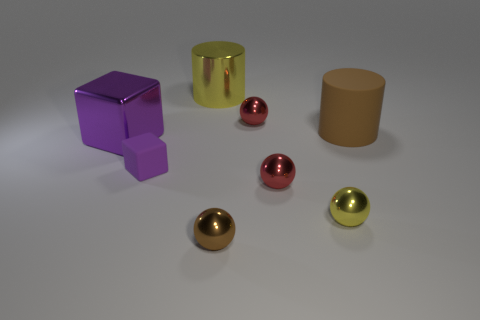There is another metallic block that is the same color as the tiny block; what is its size?
Offer a terse response. Large. Are there more red things than small metallic spheres?
Keep it short and to the point. No. What number of other objects are there of the same color as the large metal cylinder?
Provide a short and direct response. 1. Is the material of the yellow cylinder the same as the purple object in front of the large purple thing?
Give a very brief answer. No. What number of tiny red things are left of the small red metal object in front of the rubber object right of the brown metal thing?
Provide a succinct answer. 1. Is the number of things that are in front of the large purple shiny cube less than the number of things that are left of the matte cylinder?
Provide a short and direct response. Yes. How many other things are made of the same material as the yellow ball?
Your answer should be compact. 5. What is the material of the yellow object that is the same size as the brown sphere?
Your response must be concise. Metal. What number of yellow things are either tiny metallic balls or small things?
Your response must be concise. 1. There is a object that is both on the left side of the brown metallic sphere and behind the brown cylinder; what is its color?
Your response must be concise. Yellow. 